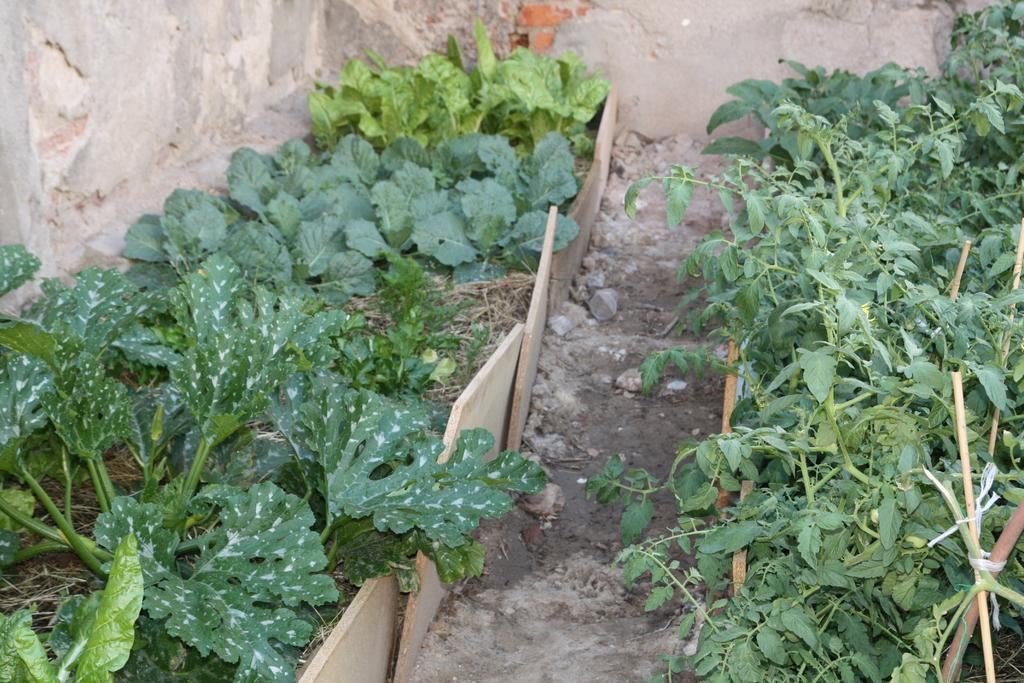What type of plants can be seen in the image? There are green color plants in the image. What objects are present in the image besides the plants? There are boards visible in the image. What can be seen in the background of the image? There is a wall visible in the background of the image. Can you describe the tiger's behavior in the image? There is no tiger present in the image, so it is not possible to describe its behavior. 